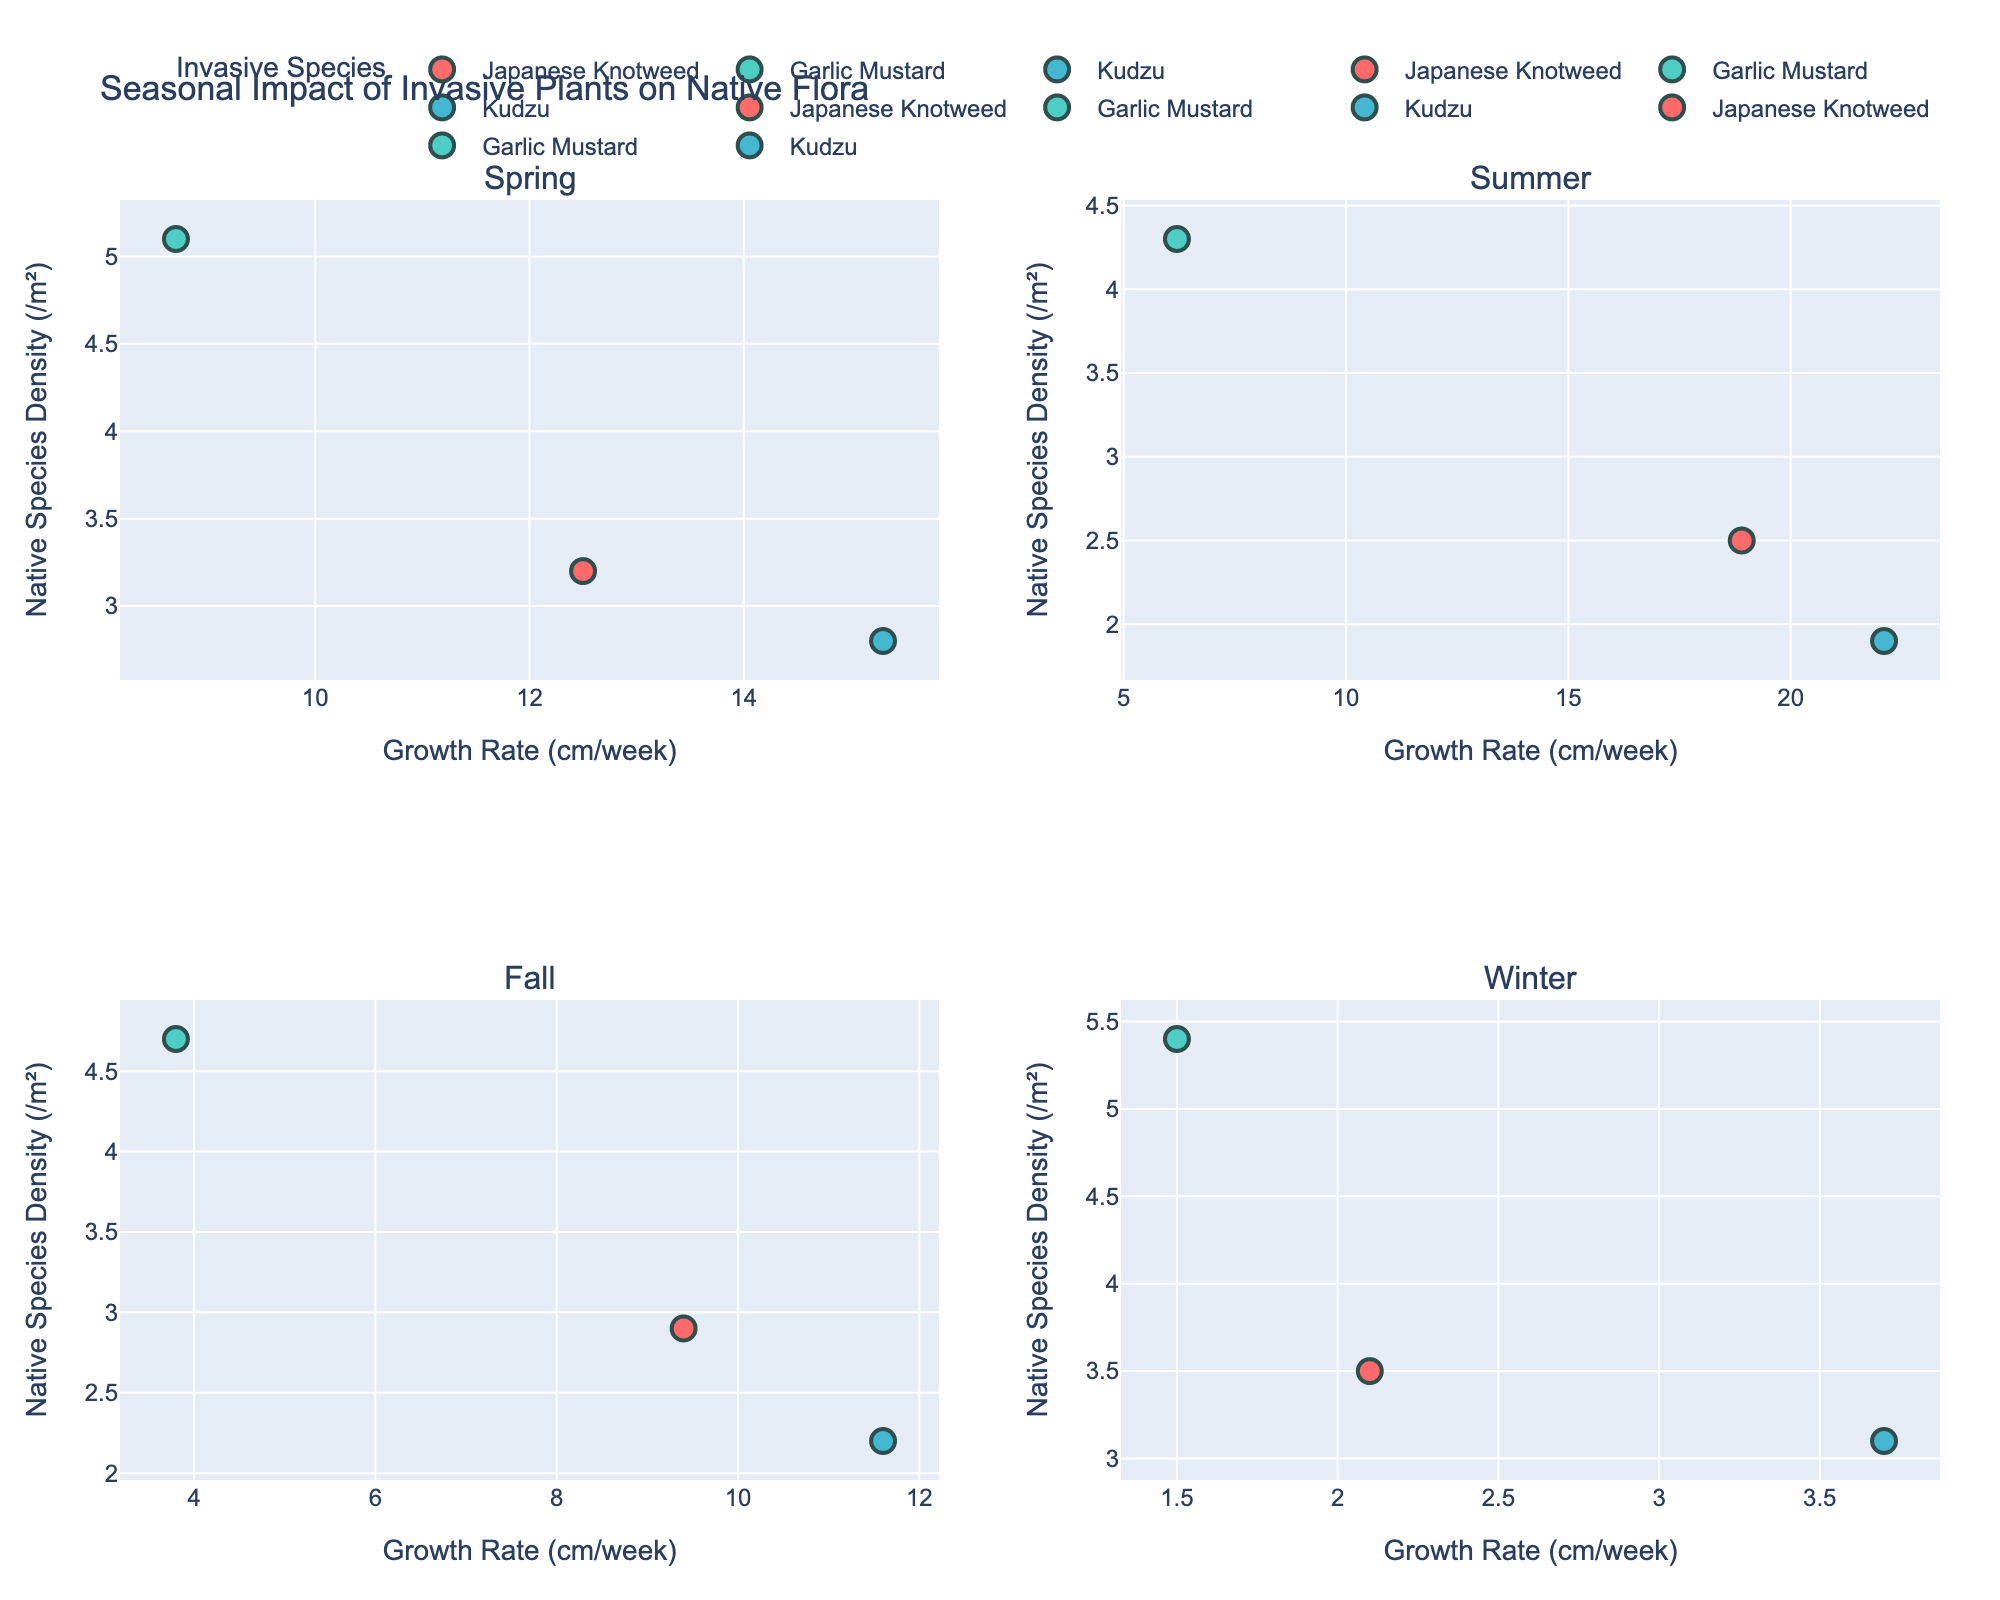What is the title of the figure? The title of the figure is located at the top-center of the plot, representing the main topic being visualized.
Answer: Seasonal Impact of Invasive Plants on Native Flora Which native species has the highest population density in winter? Look at the winter subplot at the bottom-right and identify the highest point on the y-axis, then refer to the hover text for the native species.
Answer: Virginia Bluebells Between Japanese Knotweed and Garlic Mustard, which shows a higher growth rate in summer and by how much? In the summer subplot (top-right), compare the x-coordinates (growth rates) of Japanese Knotweed and Garlic Mustard. Japanese Knotweed has a growth rate of 18.9 cm/week and Garlic Mustard has 6.2 cm/week. Subtract the lesser from the greater.
Answer: Japanese Knotweed by 12.7 cm/week How does seasonal variation affect the growth rate of Kudzu? Compare the growth rates (x-axis) of Kudzu across all four subplots. Kudzu grows 15.3 cm/week in spring, 22.1 cm/week in summer, 11.6 cm/week in fall, and 3.7 cm/week in winter. Observe the pattern.
Answer: Fastest in summer, slowest in winter What is the overall trend in native species density for Trillium across seasons? Look for the y-axis values associated with Trillium in each subplot and observe how they change: Spring (3.2), Summer (2.5), Fall (2.9), Winter (3.5). Describe the trends.
Answer: Decreases in summer, increases in winter Which invasive species shows a decrease in growth rate from summer to fall? Compare the x-coordinates (growth rates) of each species from the summer (top-right) to fall (bottom-left) subplots. Japanese Knotweed decreases from 18.9 cm/week to 9.4 cm/week.
Answer: Japanese Knotweed In which season does Garlic Mustard have the lowest growth rate, and what is that rate? Look at the four subplots and find the lowest x-coordinate for Garlic Mustard. The lowest growth rate is in winter with 1.5 cm/week.
Answer: Winter, 1.5 cm/week How does the native species density of Bloodroot change from spring to summer? Note the y-coordinates (population density) for Bloodroot in spring (2.8) and summer (1.9), then calculate the difference between them.
Answer: Decreases by 0.9 Which invasive species has the highest average growth rate over the seasons? Determine the growth rates for each invasive species in all seasons, sum them, and divide by the number of seasons. Japanese Knotweed (12.5+18.9+9.4+2.1)/4, Garlic Mustard (8.7+6.2+3.8+1.5)/4, Kudzu (15.3+22.1+11.6+3.7)/4. Compare the averages.
Answer: Kudzu What correlation, if any, can be observed between growth rate of invasive species and density of native species? Review scatter plots in each subplot for Japanese Knotweed, Garlic Mustard, and Kudzu, and describe any visible trends between x-axis (growth rate) and y-axis (native species density).
Answer: Higher invasive growth generally correlates with lower native species density 